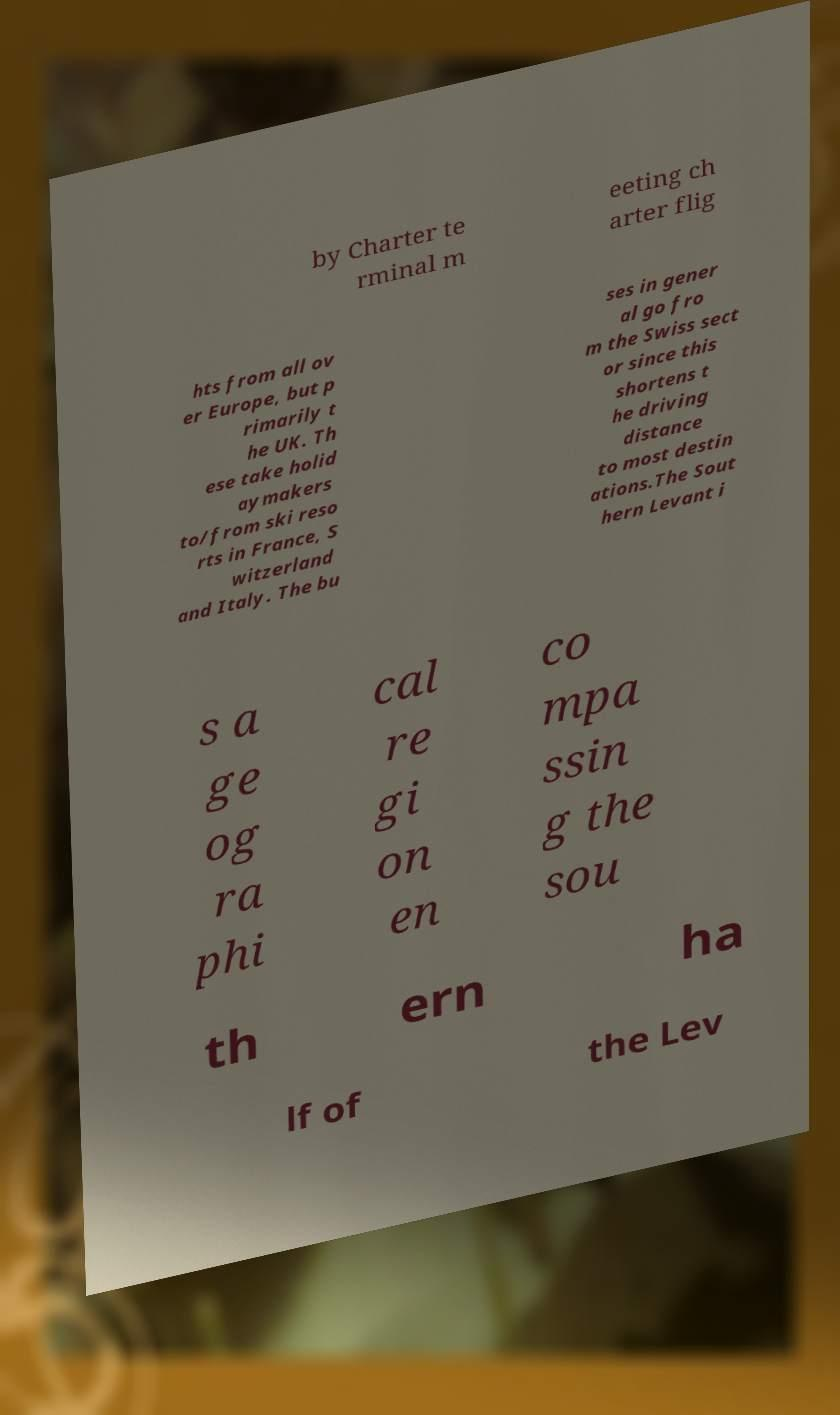I need the written content from this picture converted into text. Can you do that? by Charter te rminal m eeting ch arter flig hts from all ov er Europe, but p rimarily t he UK. Th ese take holid aymakers to/from ski reso rts in France, S witzerland and Italy. The bu ses in gener al go fro m the Swiss sect or since this shortens t he driving distance to most destin ations.The Sout hern Levant i s a ge og ra phi cal re gi on en co mpa ssin g the sou th ern ha lf of the Lev 